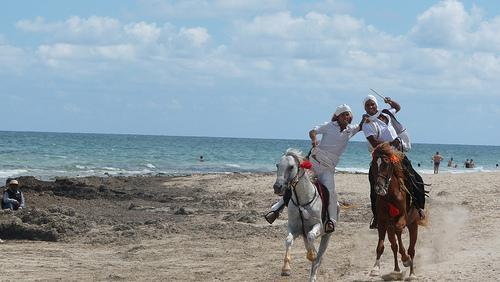How many horses are there?
Give a very brief answer. 2. 